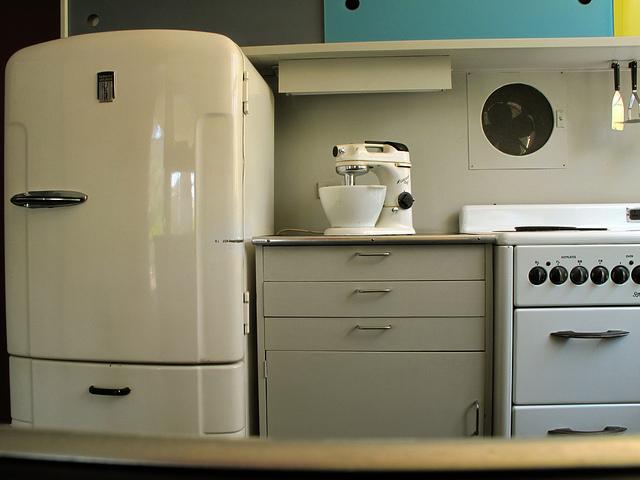What is the device on the left called?
Short answer required. Refrigerator. How many jobs are on the stove?
Keep it brief. 6. Is the ice box new?
Short answer required. No. 